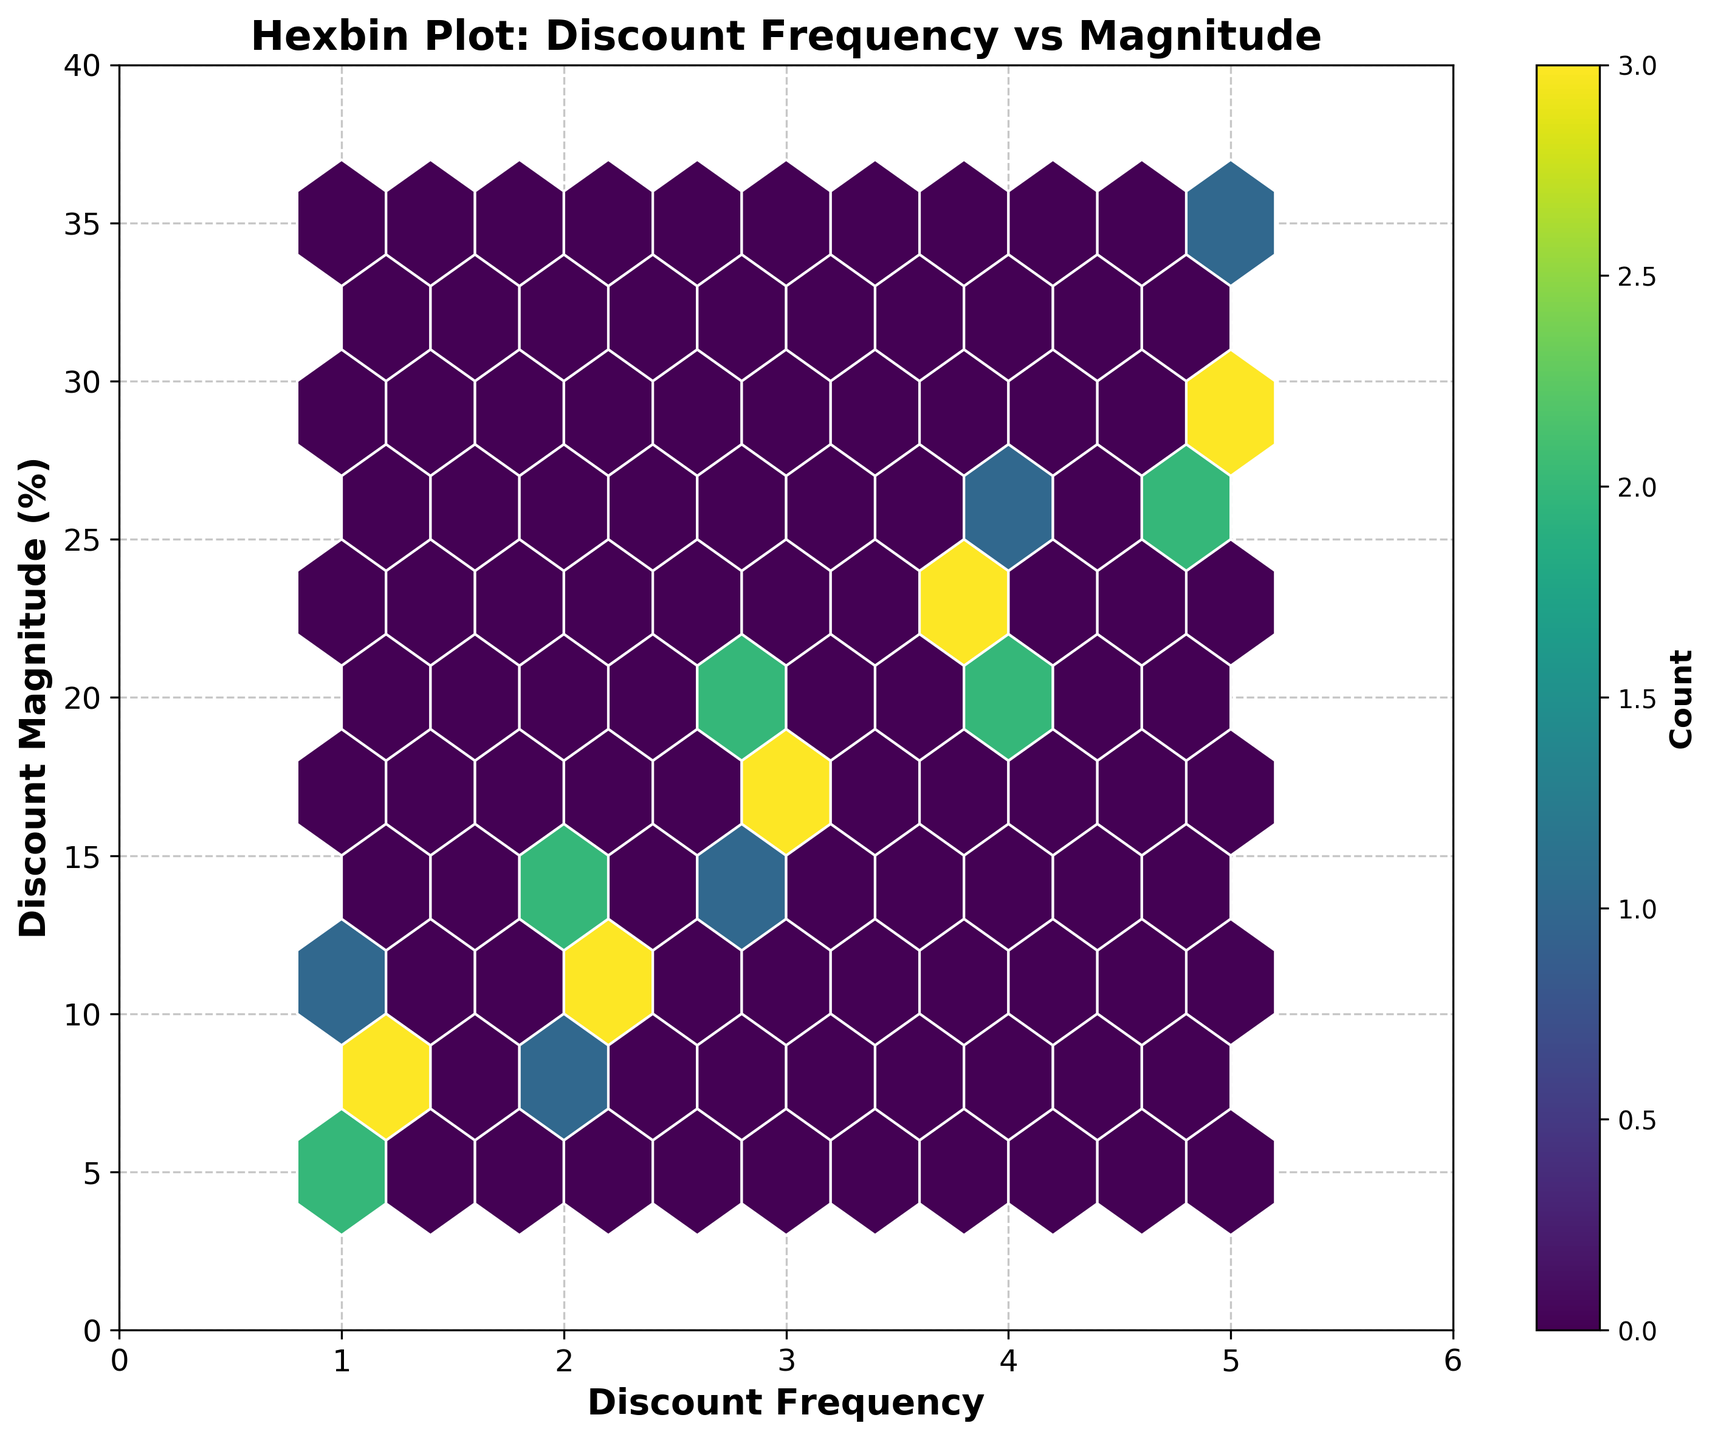What is the title of the hexbin plot? The title is written at the top of the plot. It indicates the main subject of the visualization.
Answer: Hexbin Plot: Discount Frequency vs Magnitude What are the labels of the axes? The labels are located along the x- and y-axes to describe what each axis represents. For the x-axis, the label is "Discount Frequency", and for the y-axis, the label is "Discount Magnitude (%)".
Answer: Discount Frequency (x-axis), Discount Magnitude (%) (y-axis) What does the color represent in the plot? The color intensities in the hexbin plot indicate the count of data points within each hexagonal bin. The color bar helps to understand the scale from lower counts to higher counts.
Answer: Count of data points What is the relationship between discount frequency and discount magnitude visible in the plot? By observing the plot, one can identify if there's a discernible pattern or clustering of data points, indicating any correlation between the two variables.
Answer: More frequent discounts tend to have slightly higher magnitudes Compare the number of data points at discount frequency 1 with those at discount frequency 5. To compare the number of data points, observe the color intensity of the hexagons at both frequencies. Discount frequency 5 shows darker colors indicating more data points compared to discount frequency 1.
Answer: Discount frequency 5 has more data points What's the approximate range of discount magnitudes when the discount frequency is 3? The y-axis values for the hexagons around the x-axis value of 3 indicate the range. The hexagons suggest that discount magnitudes range from approximately 15% to 20%.
Answer: Approximately 15% to 20% What's the average discount magnitude when the discount frequency is 4? Identify the central y-axis value around x=4 by observing the hexagon clustering. The average appears to be around the midpoint of the vertical spread, approximately near 22%.
Answer: Approximately 22% Is there any discount frequency with a magnitude greater than 30%? By referring to the highest point on the y-axis, one can see whether any hexagons at a specific frequency correspond to magnitudes exceeding 30%.
Answer: Yes, at discount frequency 5 Which discount frequency has the highest count of exact values? The hexagon with the darkest color represents the highest count. Identify the corresponding x-axis value.
Answer: Approximately 5 What is the maximum discount magnitude shown in the plot? Check the upper limit of the y-axis and observe if any data points hit that limit. The hexagons extend up to 35%.
Answer: 35% 